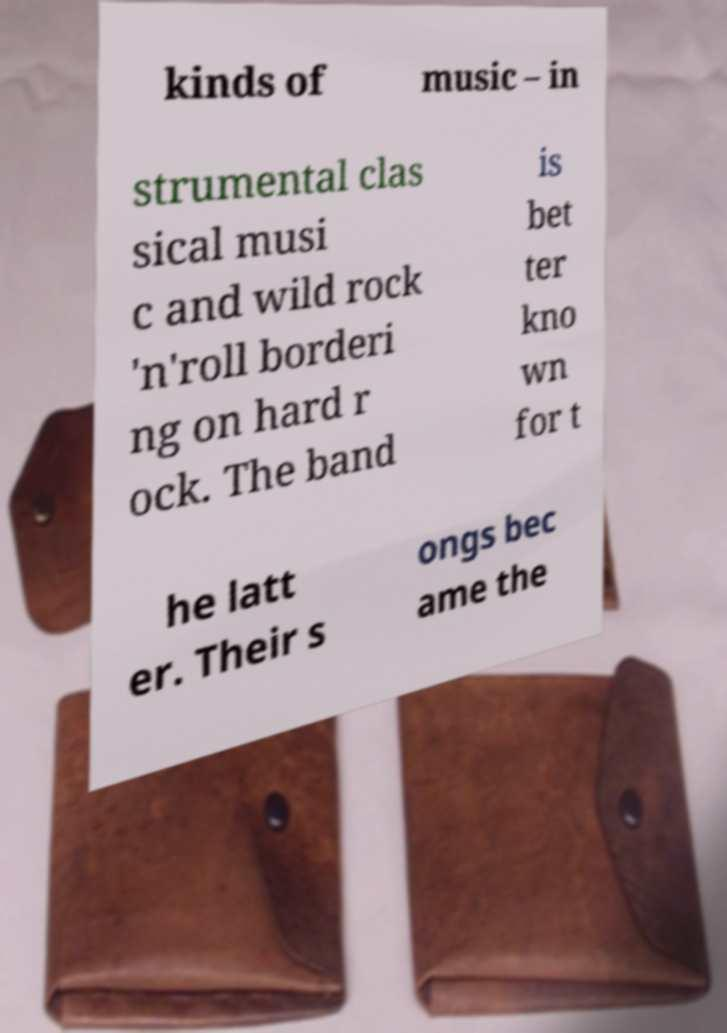Can you read and provide the text displayed in the image?This photo seems to have some interesting text. Can you extract and type it out for me? kinds of music – in strumental clas sical musi c and wild rock 'n'roll borderi ng on hard r ock. The band is bet ter kno wn for t he latt er. Their s ongs bec ame the 